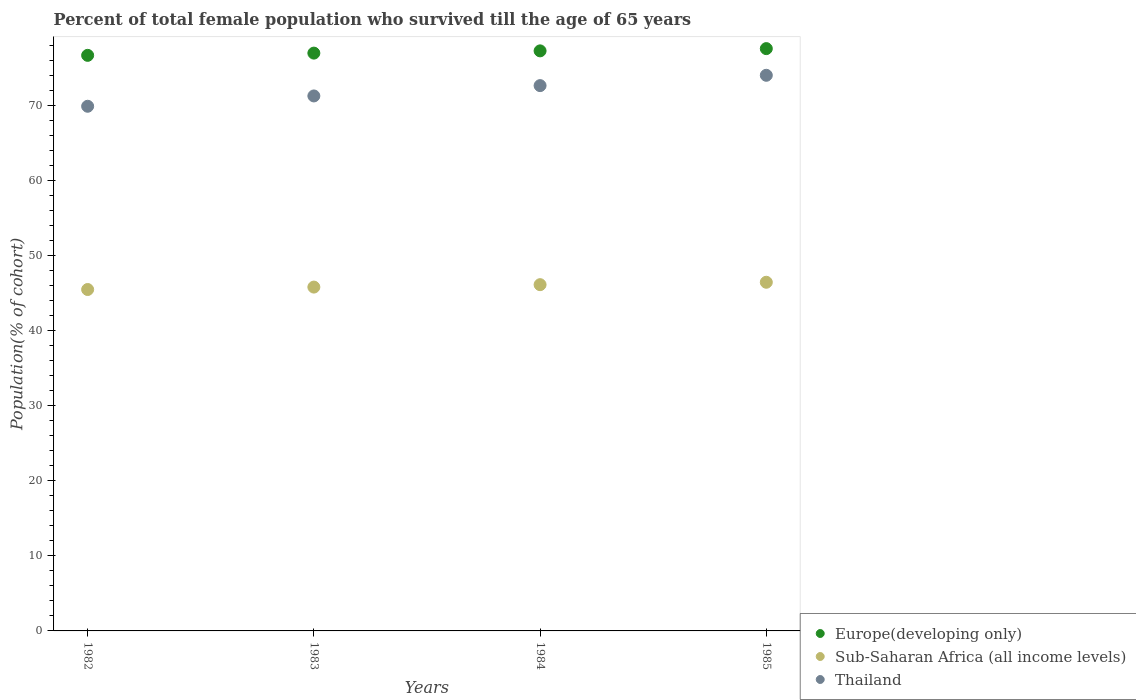What is the percentage of total female population who survived till the age of 65 years in Thailand in 1983?
Your answer should be very brief. 71.25. Across all years, what is the maximum percentage of total female population who survived till the age of 65 years in Sub-Saharan Africa (all income levels)?
Give a very brief answer. 46.44. Across all years, what is the minimum percentage of total female population who survived till the age of 65 years in Sub-Saharan Africa (all income levels)?
Your answer should be very brief. 45.47. In which year was the percentage of total female population who survived till the age of 65 years in Thailand minimum?
Provide a succinct answer. 1982. What is the total percentage of total female population who survived till the age of 65 years in Europe(developing only) in the graph?
Keep it short and to the point. 308.42. What is the difference between the percentage of total female population who survived till the age of 65 years in Thailand in 1983 and that in 1985?
Give a very brief answer. -2.75. What is the difference between the percentage of total female population who survived till the age of 65 years in Europe(developing only) in 1984 and the percentage of total female population who survived till the age of 65 years in Thailand in 1982?
Your answer should be compact. 7.38. What is the average percentage of total female population who survived till the age of 65 years in Sub-Saharan Africa (all income levels) per year?
Make the answer very short. 45.95. In the year 1982, what is the difference between the percentage of total female population who survived till the age of 65 years in Sub-Saharan Africa (all income levels) and percentage of total female population who survived till the age of 65 years in Thailand?
Provide a short and direct response. -24.41. In how many years, is the percentage of total female population who survived till the age of 65 years in Europe(developing only) greater than 22 %?
Your answer should be very brief. 4. What is the ratio of the percentage of total female population who survived till the age of 65 years in Thailand in 1982 to that in 1984?
Your response must be concise. 0.96. Is the percentage of total female population who survived till the age of 65 years in Thailand in 1983 less than that in 1985?
Your response must be concise. Yes. What is the difference between the highest and the second highest percentage of total female population who survived till the age of 65 years in Sub-Saharan Africa (all income levels)?
Provide a short and direct response. 0.32. What is the difference between the highest and the lowest percentage of total female population who survived till the age of 65 years in Sub-Saharan Africa (all income levels)?
Your answer should be compact. 0.97. Is the sum of the percentage of total female population who survived till the age of 65 years in Thailand in 1982 and 1984 greater than the maximum percentage of total female population who survived till the age of 65 years in Sub-Saharan Africa (all income levels) across all years?
Keep it short and to the point. Yes. Is it the case that in every year, the sum of the percentage of total female population who survived till the age of 65 years in Thailand and percentage of total female population who survived till the age of 65 years in Europe(developing only)  is greater than the percentage of total female population who survived till the age of 65 years in Sub-Saharan Africa (all income levels)?
Make the answer very short. Yes. Is the percentage of total female population who survived till the age of 65 years in Thailand strictly less than the percentage of total female population who survived till the age of 65 years in Sub-Saharan Africa (all income levels) over the years?
Keep it short and to the point. No. How many dotlines are there?
Provide a short and direct response. 3. What is the difference between two consecutive major ticks on the Y-axis?
Give a very brief answer. 10. Are the values on the major ticks of Y-axis written in scientific E-notation?
Your answer should be very brief. No. Where does the legend appear in the graph?
Make the answer very short. Bottom right. How are the legend labels stacked?
Give a very brief answer. Vertical. What is the title of the graph?
Your response must be concise. Percent of total female population who survived till the age of 65 years. What is the label or title of the X-axis?
Your answer should be compact. Years. What is the label or title of the Y-axis?
Make the answer very short. Population(% of cohort). What is the Population(% of cohort) in Europe(developing only) in 1982?
Offer a terse response. 76.66. What is the Population(% of cohort) of Sub-Saharan Africa (all income levels) in 1982?
Your answer should be compact. 45.47. What is the Population(% of cohort) of Thailand in 1982?
Keep it short and to the point. 69.88. What is the Population(% of cohort) of Europe(developing only) in 1983?
Your response must be concise. 76.95. What is the Population(% of cohort) of Sub-Saharan Africa (all income levels) in 1983?
Offer a very short reply. 45.79. What is the Population(% of cohort) of Thailand in 1983?
Offer a terse response. 71.25. What is the Population(% of cohort) in Europe(developing only) in 1984?
Offer a terse response. 77.25. What is the Population(% of cohort) in Sub-Saharan Africa (all income levels) in 1984?
Keep it short and to the point. 46.12. What is the Population(% of cohort) of Thailand in 1984?
Offer a terse response. 72.63. What is the Population(% of cohort) of Europe(developing only) in 1985?
Your answer should be compact. 77.55. What is the Population(% of cohort) in Sub-Saharan Africa (all income levels) in 1985?
Your response must be concise. 46.44. What is the Population(% of cohort) in Thailand in 1985?
Your response must be concise. 74. Across all years, what is the maximum Population(% of cohort) of Europe(developing only)?
Your response must be concise. 77.55. Across all years, what is the maximum Population(% of cohort) of Sub-Saharan Africa (all income levels)?
Make the answer very short. 46.44. Across all years, what is the maximum Population(% of cohort) in Thailand?
Ensure brevity in your answer.  74. Across all years, what is the minimum Population(% of cohort) in Europe(developing only)?
Your answer should be compact. 76.66. Across all years, what is the minimum Population(% of cohort) of Sub-Saharan Africa (all income levels)?
Your response must be concise. 45.47. Across all years, what is the minimum Population(% of cohort) of Thailand?
Your response must be concise. 69.88. What is the total Population(% of cohort) in Europe(developing only) in the graph?
Keep it short and to the point. 308.42. What is the total Population(% of cohort) in Sub-Saharan Africa (all income levels) in the graph?
Your answer should be very brief. 183.81. What is the total Population(% of cohort) in Thailand in the graph?
Provide a succinct answer. 287.75. What is the difference between the Population(% of cohort) of Europe(developing only) in 1982 and that in 1983?
Your answer should be compact. -0.3. What is the difference between the Population(% of cohort) in Sub-Saharan Africa (all income levels) in 1982 and that in 1983?
Ensure brevity in your answer.  -0.32. What is the difference between the Population(% of cohort) of Thailand in 1982 and that in 1983?
Provide a succinct answer. -1.38. What is the difference between the Population(% of cohort) in Europe(developing only) in 1982 and that in 1984?
Your response must be concise. -0.6. What is the difference between the Population(% of cohort) of Sub-Saharan Africa (all income levels) in 1982 and that in 1984?
Provide a short and direct response. -0.64. What is the difference between the Population(% of cohort) of Thailand in 1982 and that in 1984?
Give a very brief answer. -2.75. What is the difference between the Population(% of cohort) of Europe(developing only) in 1982 and that in 1985?
Provide a succinct answer. -0.9. What is the difference between the Population(% of cohort) of Sub-Saharan Africa (all income levels) in 1982 and that in 1985?
Provide a succinct answer. -0.97. What is the difference between the Population(% of cohort) in Thailand in 1982 and that in 1985?
Offer a very short reply. -4.13. What is the difference between the Population(% of cohort) of Europe(developing only) in 1983 and that in 1984?
Make the answer very short. -0.3. What is the difference between the Population(% of cohort) of Sub-Saharan Africa (all income levels) in 1983 and that in 1984?
Your response must be concise. -0.32. What is the difference between the Population(% of cohort) of Thailand in 1983 and that in 1984?
Provide a short and direct response. -1.38. What is the difference between the Population(% of cohort) of Europe(developing only) in 1983 and that in 1985?
Your answer should be compact. -0.6. What is the difference between the Population(% of cohort) in Sub-Saharan Africa (all income levels) in 1983 and that in 1985?
Provide a succinct answer. -0.64. What is the difference between the Population(% of cohort) in Thailand in 1983 and that in 1985?
Keep it short and to the point. -2.75. What is the difference between the Population(% of cohort) of Europe(developing only) in 1984 and that in 1985?
Your answer should be very brief. -0.3. What is the difference between the Population(% of cohort) in Sub-Saharan Africa (all income levels) in 1984 and that in 1985?
Offer a very short reply. -0.32. What is the difference between the Population(% of cohort) of Thailand in 1984 and that in 1985?
Make the answer very short. -1.38. What is the difference between the Population(% of cohort) in Europe(developing only) in 1982 and the Population(% of cohort) in Sub-Saharan Africa (all income levels) in 1983?
Your answer should be very brief. 30.86. What is the difference between the Population(% of cohort) of Europe(developing only) in 1982 and the Population(% of cohort) of Thailand in 1983?
Your response must be concise. 5.41. What is the difference between the Population(% of cohort) in Sub-Saharan Africa (all income levels) in 1982 and the Population(% of cohort) in Thailand in 1983?
Keep it short and to the point. -25.78. What is the difference between the Population(% of cohort) of Europe(developing only) in 1982 and the Population(% of cohort) of Sub-Saharan Africa (all income levels) in 1984?
Ensure brevity in your answer.  30.54. What is the difference between the Population(% of cohort) of Europe(developing only) in 1982 and the Population(% of cohort) of Thailand in 1984?
Your answer should be very brief. 4.03. What is the difference between the Population(% of cohort) in Sub-Saharan Africa (all income levels) in 1982 and the Population(% of cohort) in Thailand in 1984?
Your answer should be compact. -27.16. What is the difference between the Population(% of cohort) of Europe(developing only) in 1982 and the Population(% of cohort) of Sub-Saharan Africa (all income levels) in 1985?
Your answer should be compact. 30.22. What is the difference between the Population(% of cohort) of Europe(developing only) in 1982 and the Population(% of cohort) of Thailand in 1985?
Your response must be concise. 2.66. What is the difference between the Population(% of cohort) in Sub-Saharan Africa (all income levels) in 1982 and the Population(% of cohort) in Thailand in 1985?
Provide a succinct answer. -28.53. What is the difference between the Population(% of cohort) of Europe(developing only) in 1983 and the Population(% of cohort) of Sub-Saharan Africa (all income levels) in 1984?
Keep it short and to the point. 30.84. What is the difference between the Population(% of cohort) in Europe(developing only) in 1983 and the Population(% of cohort) in Thailand in 1984?
Ensure brevity in your answer.  4.33. What is the difference between the Population(% of cohort) of Sub-Saharan Africa (all income levels) in 1983 and the Population(% of cohort) of Thailand in 1984?
Your response must be concise. -26.83. What is the difference between the Population(% of cohort) of Europe(developing only) in 1983 and the Population(% of cohort) of Sub-Saharan Africa (all income levels) in 1985?
Give a very brief answer. 30.52. What is the difference between the Population(% of cohort) of Europe(developing only) in 1983 and the Population(% of cohort) of Thailand in 1985?
Provide a short and direct response. 2.95. What is the difference between the Population(% of cohort) in Sub-Saharan Africa (all income levels) in 1983 and the Population(% of cohort) in Thailand in 1985?
Make the answer very short. -28.21. What is the difference between the Population(% of cohort) of Europe(developing only) in 1984 and the Population(% of cohort) of Sub-Saharan Africa (all income levels) in 1985?
Your answer should be compact. 30.82. What is the difference between the Population(% of cohort) in Europe(developing only) in 1984 and the Population(% of cohort) in Thailand in 1985?
Offer a very short reply. 3.25. What is the difference between the Population(% of cohort) in Sub-Saharan Africa (all income levels) in 1984 and the Population(% of cohort) in Thailand in 1985?
Keep it short and to the point. -27.89. What is the average Population(% of cohort) in Europe(developing only) per year?
Your answer should be compact. 77.1. What is the average Population(% of cohort) of Sub-Saharan Africa (all income levels) per year?
Offer a very short reply. 45.95. What is the average Population(% of cohort) in Thailand per year?
Provide a succinct answer. 71.94. In the year 1982, what is the difference between the Population(% of cohort) in Europe(developing only) and Population(% of cohort) in Sub-Saharan Africa (all income levels)?
Ensure brevity in your answer.  31.19. In the year 1982, what is the difference between the Population(% of cohort) in Europe(developing only) and Population(% of cohort) in Thailand?
Ensure brevity in your answer.  6.78. In the year 1982, what is the difference between the Population(% of cohort) in Sub-Saharan Africa (all income levels) and Population(% of cohort) in Thailand?
Offer a terse response. -24.41. In the year 1983, what is the difference between the Population(% of cohort) in Europe(developing only) and Population(% of cohort) in Sub-Saharan Africa (all income levels)?
Offer a terse response. 31.16. In the year 1983, what is the difference between the Population(% of cohort) in Europe(developing only) and Population(% of cohort) in Thailand?
Provide a short and direct response. 5.7. In the year 1983, what is the difference between the Population(% of cohort) in Sub-Saharan Africa (all income levels) and Population(% of cohort) in Thailand?
Provide a succinct answer. -25.46. In the year 1984, what is the difference between the Population(% of cohort) in Europe(developing only) and Population(% of cohort) in Sub-Saharan Africa (all income levels)?
Keep it short and to the point. 31.14. In the year 1984, what is the difference between the Population(% of cohort) of Europe(developing only) and Population(% of cohort) of Thailand?
Keep it short and to the point. 4.63. In the year 1984, what is the difference between the Population(% of cohort) of Sub-Saharan Africa (all income levels) and Population(% of cohort) of Thailand?
Give a very brief answer. -26.51. In the year 1985, what is the difference between the Population(% of cohort) in Europe(developing only) and Population(% of cohort) in Sub-Saharan Africa (all income levels)?
Ensure brevity in your answer.  31.12. In the year 1985, what is the difference between the Population(% of cohort) in Europe(developing only) and Population(% of cohort) in Thailand?
Your answer should be very brief. 3.55. In the year 1985, what is the difference between the Population(% of cohort) of Sub-Saharan Africa (all income levels) and Population(% of cohort) of Thailand?
Give a very brief answer. -27.57. What is the ratio of the Population(% of cohort) of Europe(developing only) in 1982 to that in 1983?
Keep it short and to the point. 1. What is the ratio of the Population(% of cohort) of Sub-Saharan Africa (all income levels) in 1982 to that in 1983?
Give a very brief answer. 0.99. What is the ratio of the Population(% of cohort) of Thailand in 1982 to that in 1983?
Make the answer very short. 0.98. What is the ratio of the Population(% of cohort) in Thailand in 1982 to that in 1984?
Ensure brevity in your answer.  0.96. What is the ratio of the Population(% of cohort) in Europe(developing only) in 1982 to that in 1985?
Provide a short and direct response. 0.99. What is the ratio of the Population(% of cohort) in Sub-Saharan Africa (all income levels) in 1982 to that in 1985?
Your answer should be compact. 0.98. What is the ratio of the Population(% of cohort) of Thailand in 1982 to that in 1985?
Offer a terse response. 0.94. What is the ratio of the Population(% of cohort) of Europe(developing only) in 1983 to that in 1984?
Provide a succinct answer. 1. What is the ratio of the Population(% of cohort) in Thailand in 1983 to that in 1984?
Ensure brevity in your answer.  0.98. What is the ratio of the Population(% of cohort) in Europe(developing only) in 1983 to that in 1985?
Offer a terse response. 0.99. What is the ratio of the Population(% of cohort) of Sub-Saharan Africa (all income levels) in 1983 to that in 1985?
Provide a succinct answer. 0.99. What is the ratio of the Population(% of cohort) of Thailand in 1983 to that in 1985?
Your response must be concise. 0.96. What is the ratio of the Population(% of cohort) in Europe(developing only) in 1984 to that in 1985?
Give a very brief answer. 1. What is the ratio of the Population(% of cohort) in Sub-Saharan Africa (all income levels) in 1984 to that in 1985?
Your answer should be compact. 0.99. What is the ratio of the Population(% of cohort) in Thailand in 1984 to that in 1985?
Your answer should be compact. 0.98. What is the difference between the highest and the second highest Population(% of cohort) in Europe(developing only)?
Give a very brief answer. 0.3. What is the difference between the highest and the second highest Population(% of cohort) in Sub-Saharan Africa (all income levels)?
Keep it short and to the point. 0.32. What is the difference between the highest and the second highest Population(% of cohort) in Thailand?
Ensure brevity in your answer.  1.38. What is the difference between the highest and the lowest Population(% of cohort) in Europe(developing only)?
Ensure brevity in your answer.  0.9. What is the difference between the highest and the lowest Population(% of cohort) in Sub-Saharan Africa (all income levels)?
Keep it short and to the point. 0.97. What is the difference between the highest and the lowest Population(% of cohort) in Thailand?
Offer a very short reply. 4.13. 